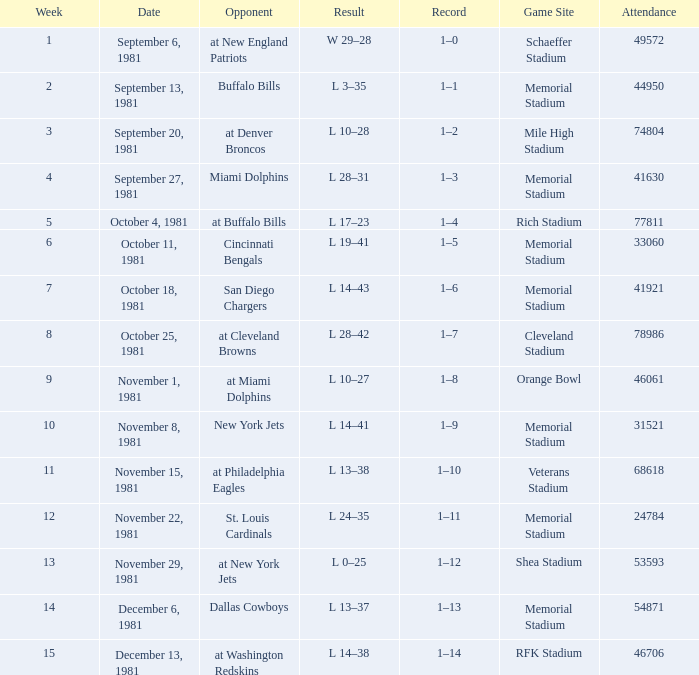On october 18, 1981, where is the location of the game? Memorial Stadium. 